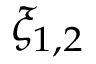Convert formula to latex. <formula><loc_0><loc_0><loc_500><loc_500>\xi _ { 1 , 2 }</formula> 